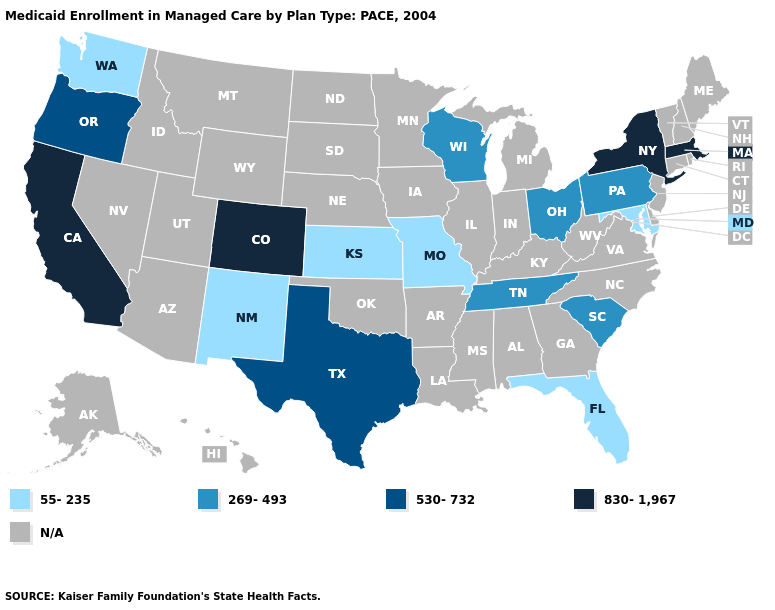Which states hav the highest value in the West?
Concise answer only. California, Colorado. Name the states that have a value in the range 269-493?
Write a very short answer. Ohio, Pennsylvania, South Carolina, Tennessee, Wisconsin. Which states have the highest value in the USA?
Concise answer only. California, Colorado, Massachusetts, New York. Name the states that have a value in the range 269-493?
Quick response, please. Ohio, Pennsylvania, South Carolina, Tennessee, Wisconsin. Name the states that have a value in the range 830-1,967?
Short answer required. California, Colorado, Massachusetts, New York. What is the value of Georgia?
Keep it brief. N/A. Name the states that have a value in the range 530-732?
Quick response, please. Oregon, Texas. What is the lowest value in the USA?
Write a very short answer. 55-235. What is the value of California?
Keep it brief. 830-1,967. Which states have the lowest value in the South?
Write a very short answer. Florida, Maryland. Name the states that have a value in the range 269-493?
Quick response, please. Ohio, Pennsylvania, South Carolina, Tennessee, Wisconsin. What is the value of Arkansas?
Be succinct. N/A. Among the states that border Iowa , which have the highest value?
Give a very brief answer. Wisconsin. Name the states that have a value in the range 530-732?
Short answer required. Oregon, Texas. 